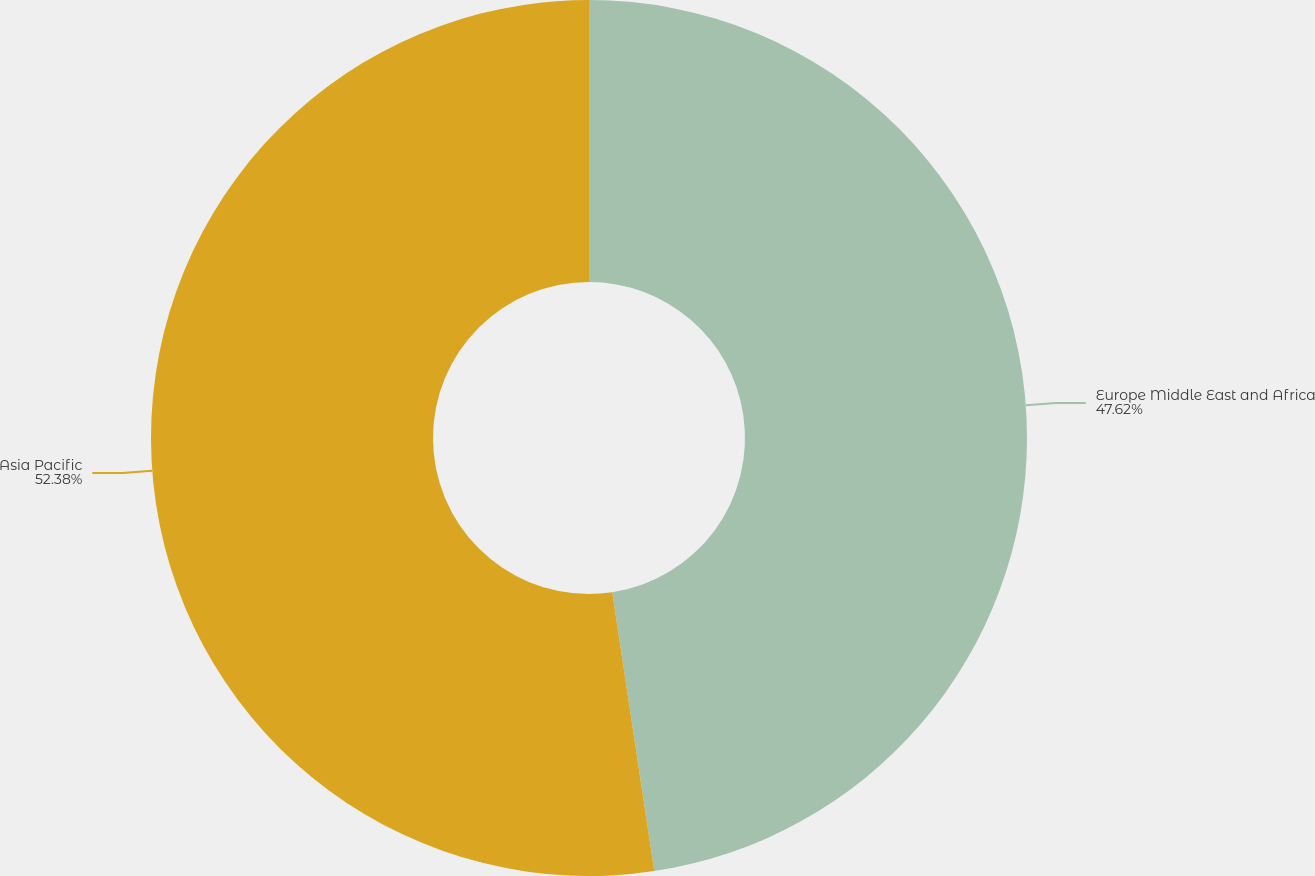<chart> <loc_0><loc_0><loc_500><loc_500><pie_chart><fcel>Europe Middle East and Africa<fcel>Asia Pacific<nl><fcel>47.62%<fcel>52.38%<nl></chart> 